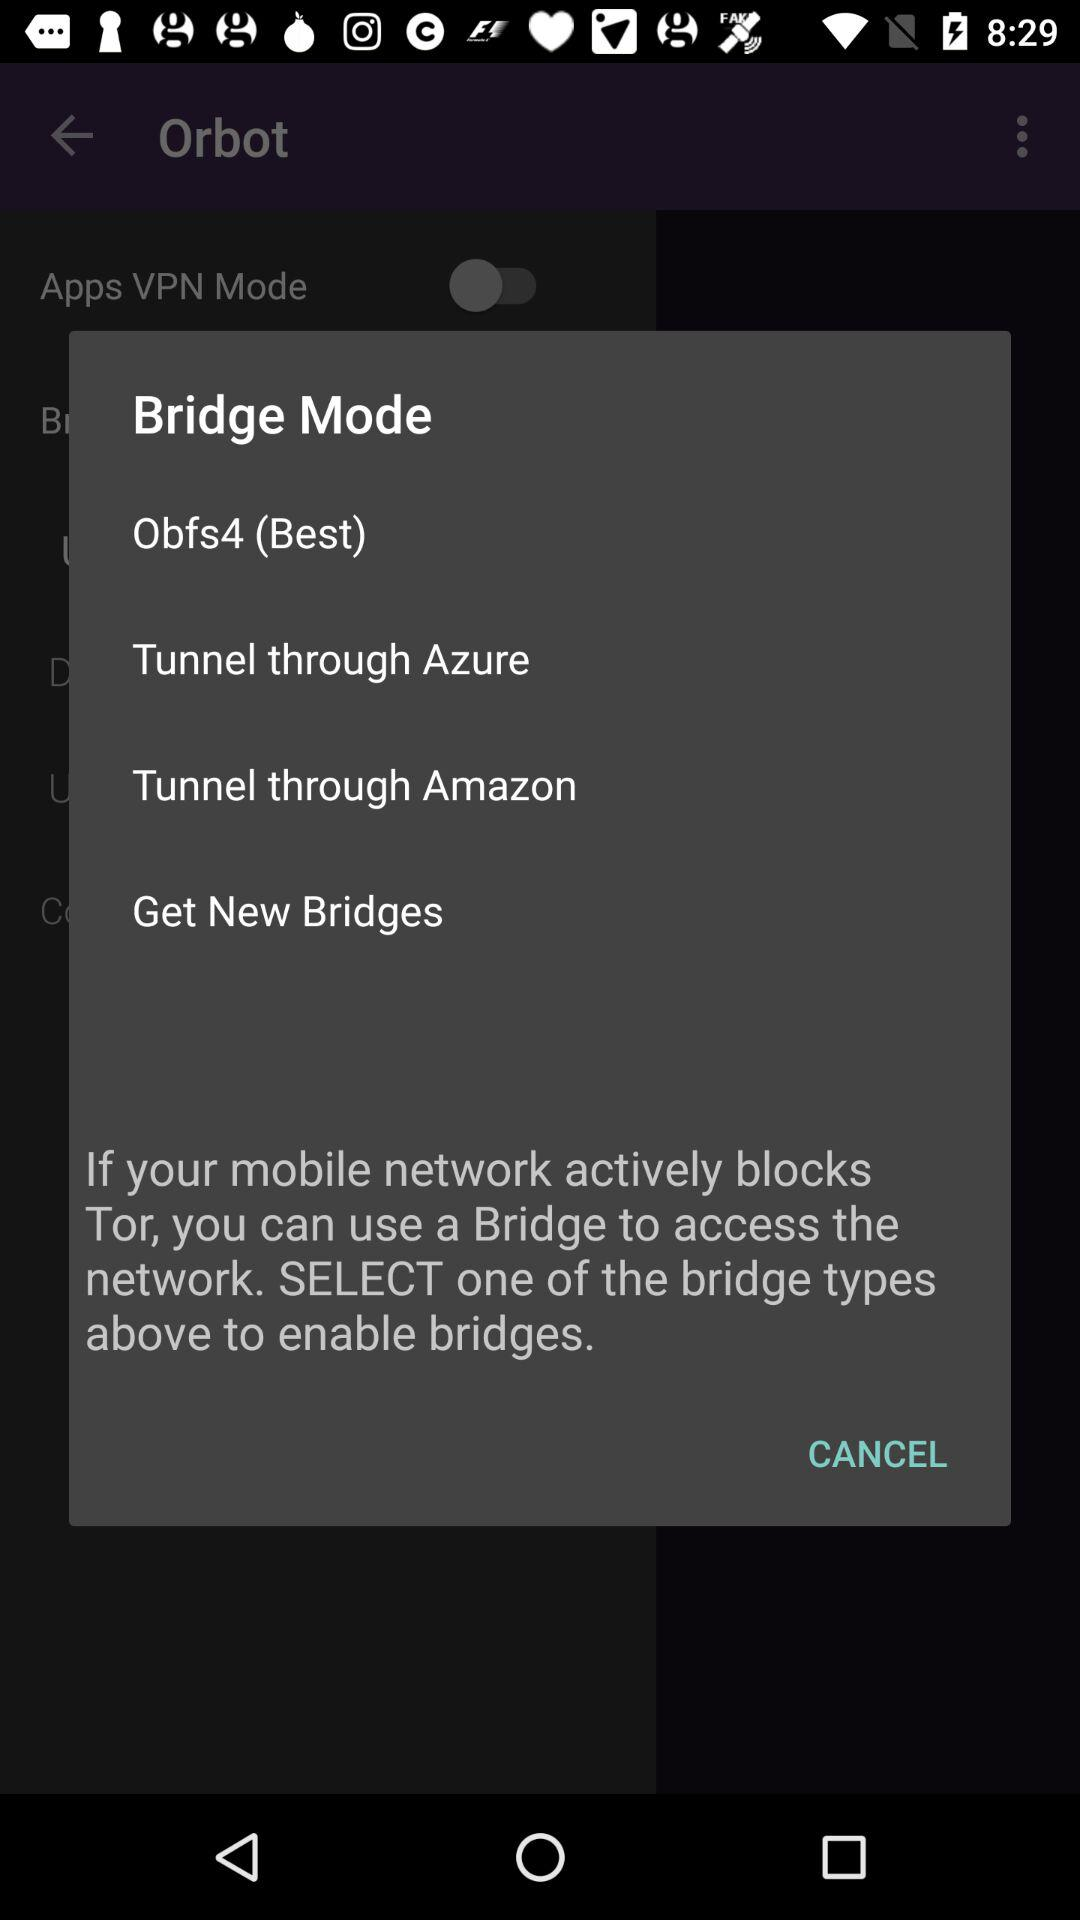How many bridge types are available?
Answer the question using a single word or phrase. 4 